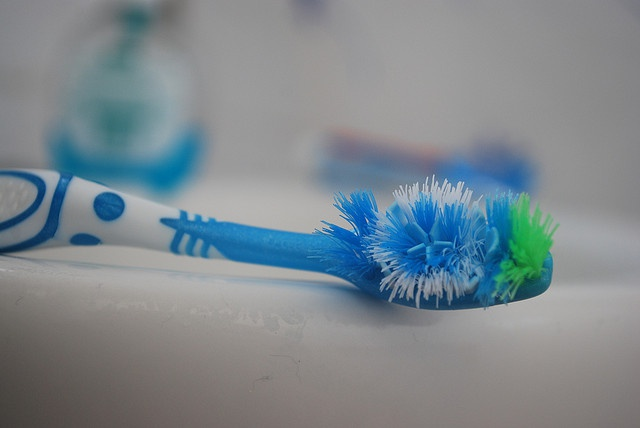Describe the objects in this image and their specific colors. I can see toothbrush in gray, blue, and darkgray tones and bottle in gray and teal tones in this image. 